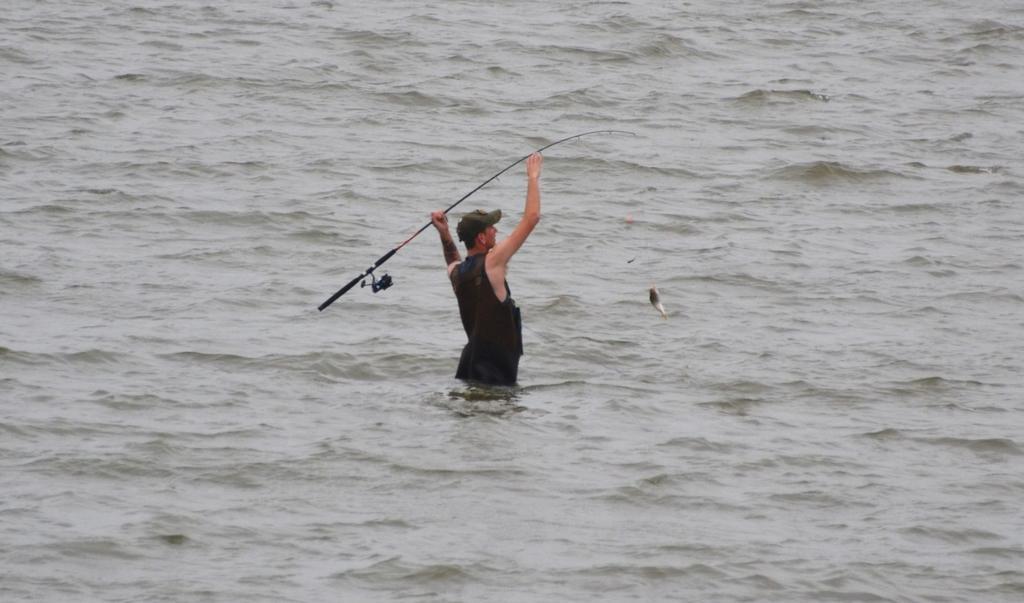How would you summarize this image in a sentence or two? There is one man present in the water and holding a fish rod as we can see in the middle of this image. 